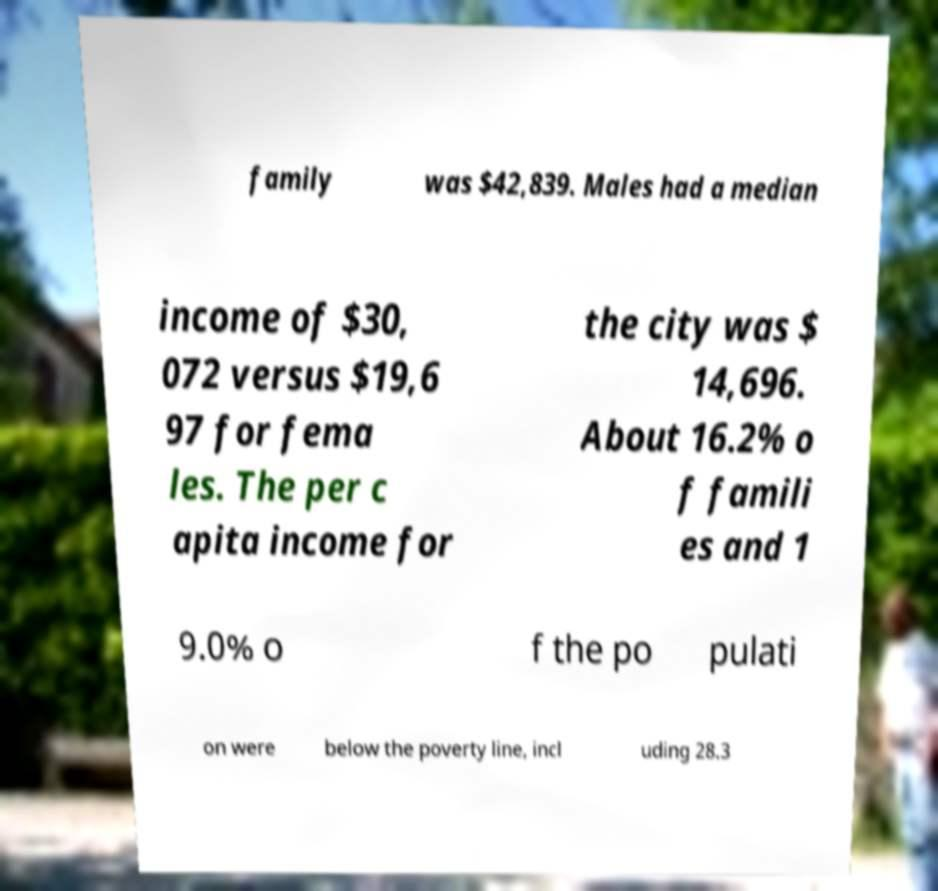I need the written content from this picture converted into text. Can you do that? family was $42,839. Males had a median income of $30, 072 versus $19,6 97 for fema les. The per c apita income for the city was $ 14,696. About 16.2% o f famili es and 1 9.0% o f the po pulati on were below the poverty line, incl uding 28.3 